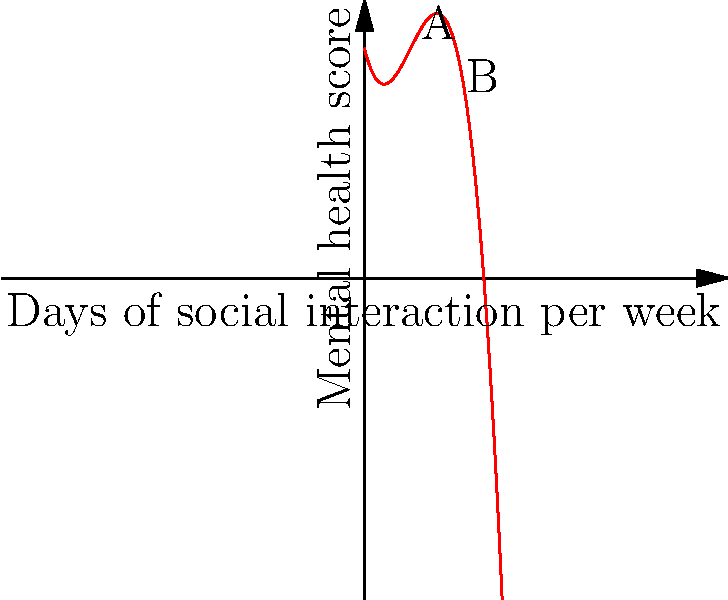A Danish mental health researcher models the relationship between social interaction and mental health during the COVID-19 pandemic using the function $f(x) = -0.5x^3 + 3x^2 - 4x + 10$, where $x$ represents the number of days per week with social interaction and $f(x)$ represents the mental health score. What is the change in mental health score when increasing social interaction from 2 to 4 days per week? To solve this problem, we need to follow these steps:

1) Calculate the mental health score for 2 days of social interaction:
   $f(2) = -0.5(2)^3 + 3(2)^2 - 4(2) + 10$
   $= -0.5(8) + 3(4) - 8 + 10$
   $= -4 + 12 - 8 + 10 = 10$

2) Calculate the mental health score for 4 days of social interaction:
   $f(4) = -0.5(4)^3 + 3(4)^2 - 4(4) + 10$
   $= -0.5(64) + 3(16) - 16 + 10$
   $= -32 + 48 - 16 + 10 = 10$

3) Calculate the change in mental health score:
   Change = $f(4) - f(2) = 10 - 10 = 0$

Therefore, there is no change in the mental health score when increasing social interaction from 2 to 4 days per week.
Answer: 0 